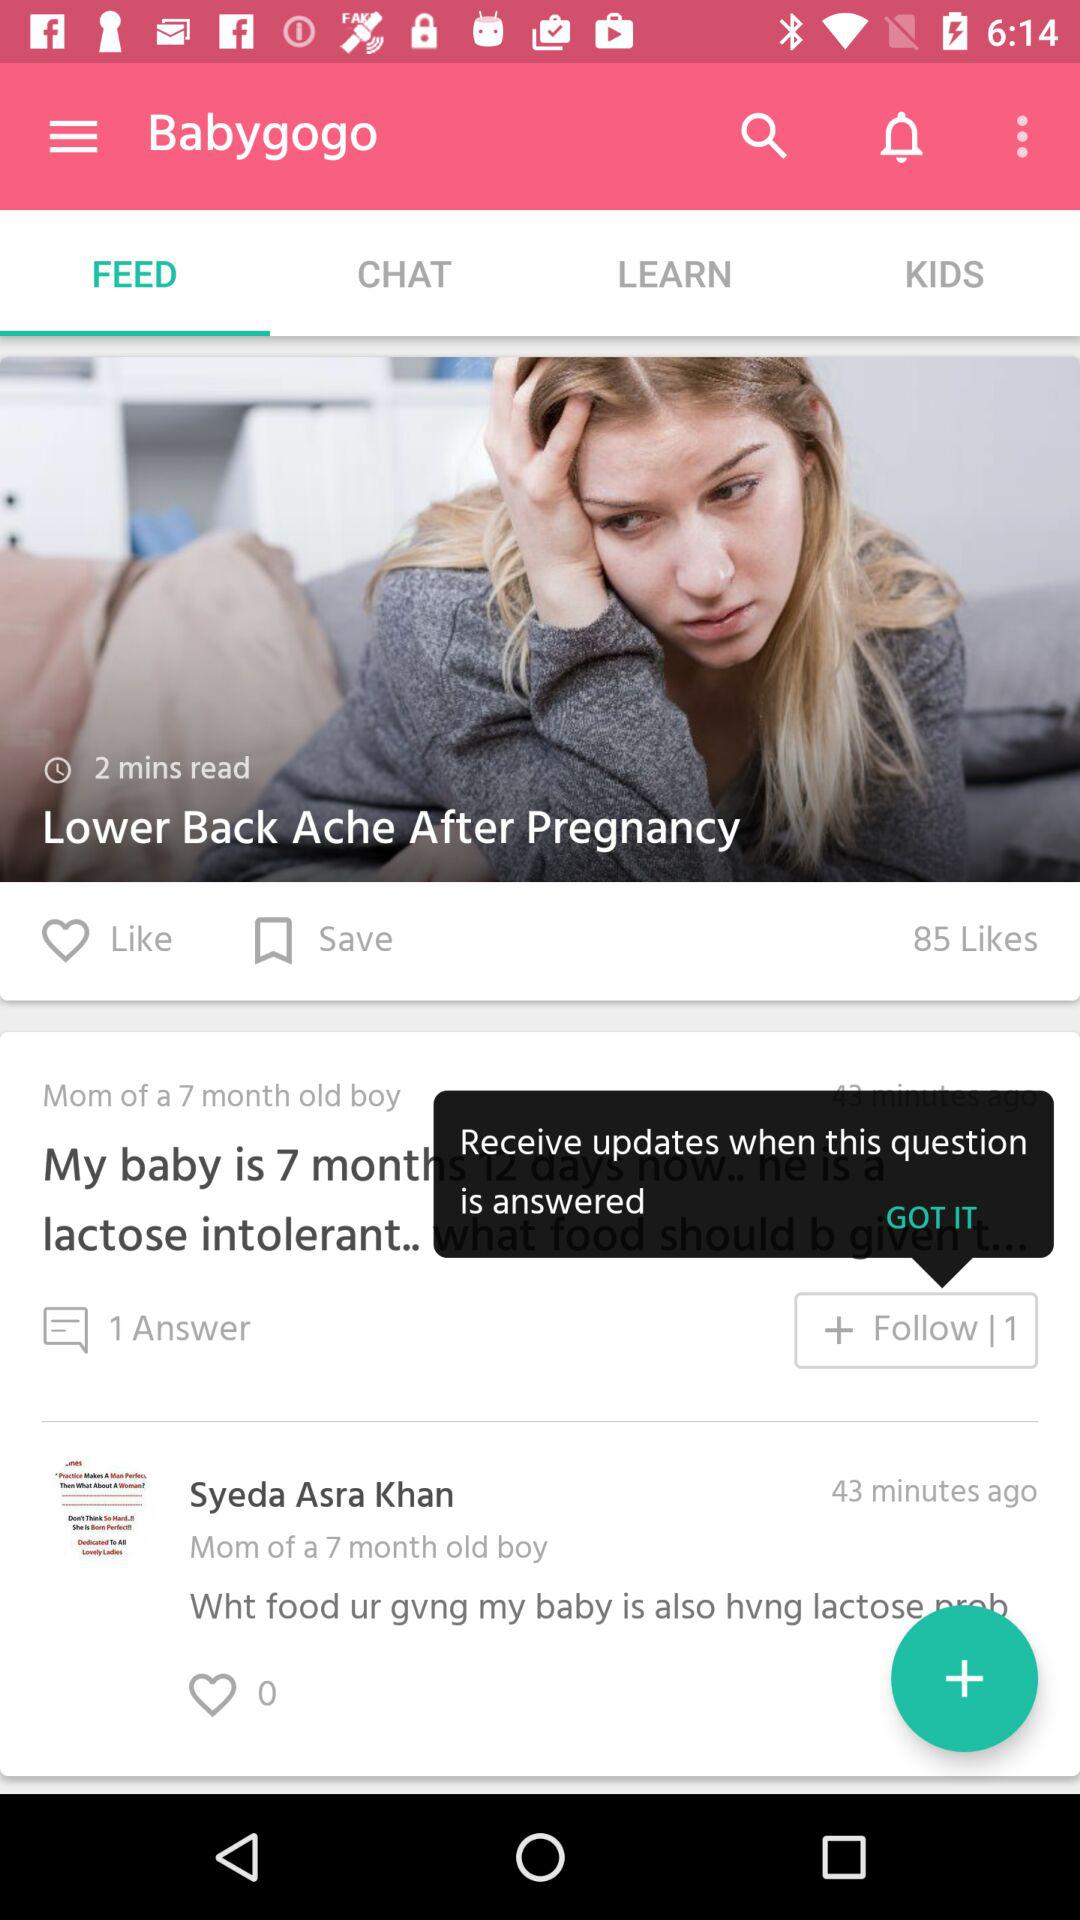Which tab has been selected? The selected tab is "FEED". 